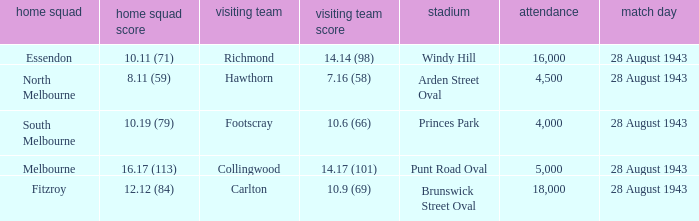What game showed a home team score of 8.11 (59)? 28 August 1943. 